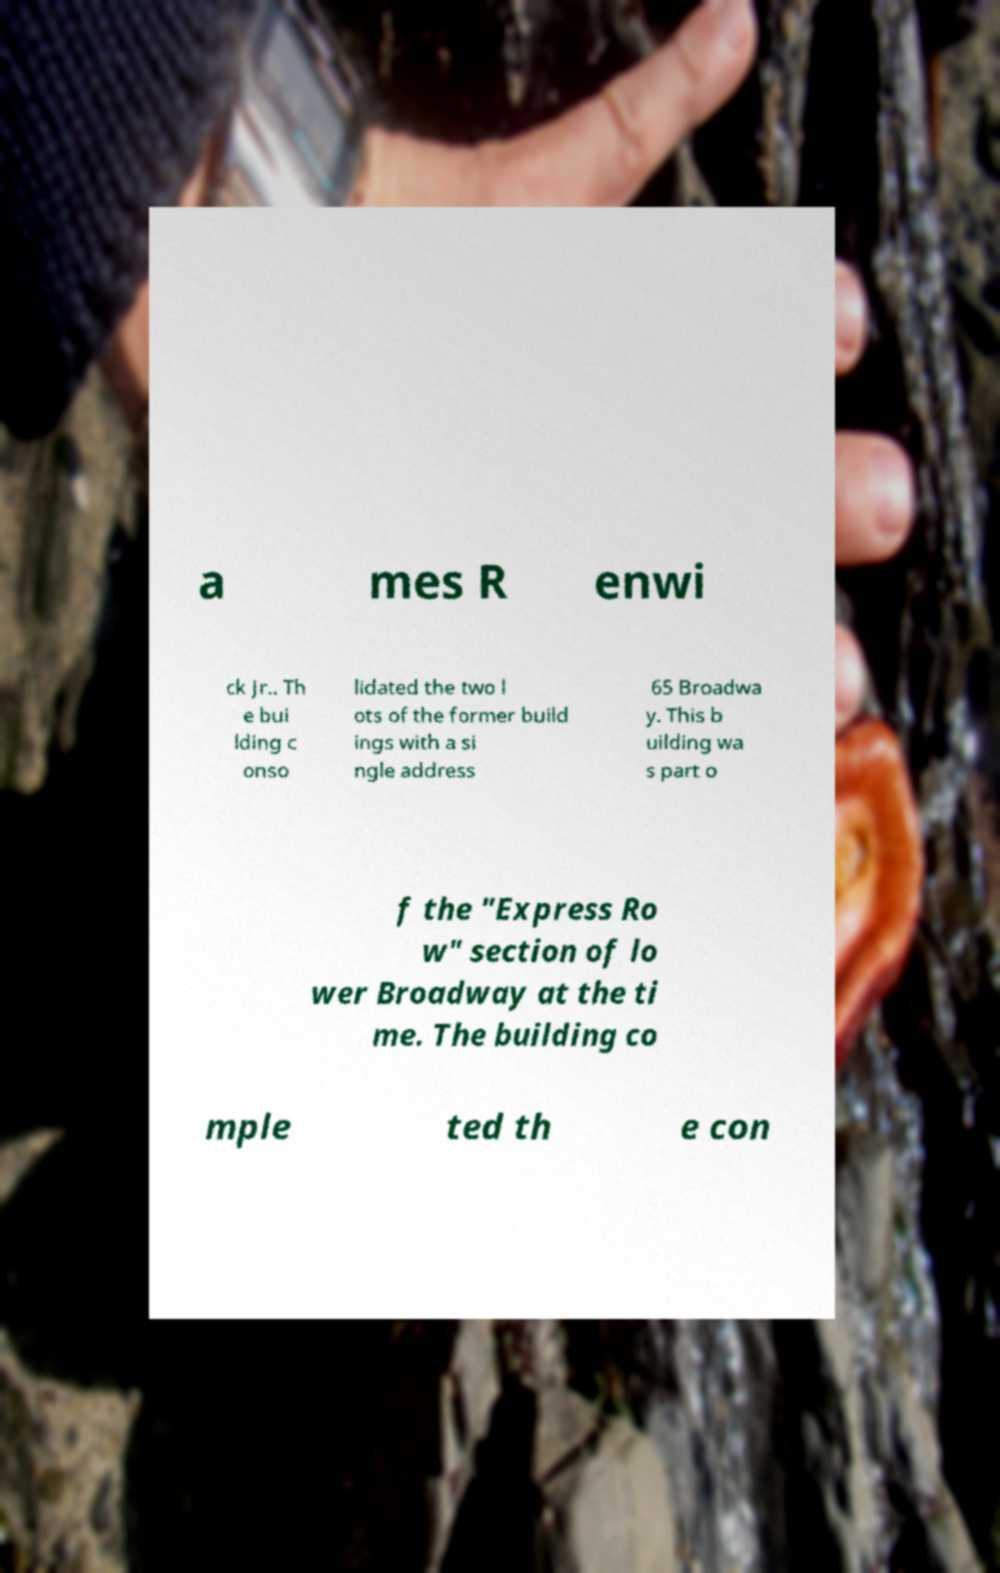What messages or text are displayed in this image? I need them in a readable, typed format. a mes R enwi ck Jr.. Th e bui lding c onso lidated the two l ots of the former build ings with a si ngle address 65 Broadwa y. This b uilding wa s part o f the "Express Ro w" section of lo wer Broadway at the ti me. The building co mple ted th e con 